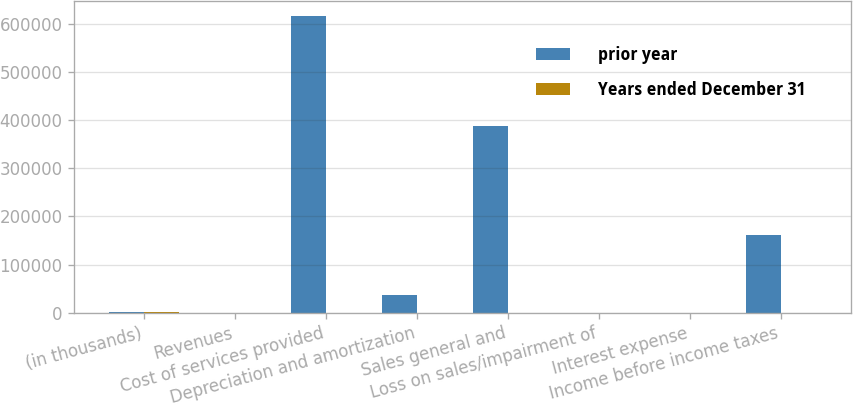Convert chart. <chart><loc_0><loc_0><loc_500><loc_500><stacked_bar_chart><ecel><fcel>(in thousands)<fcel>Revenues<fcel>Cost of services provided<fcel>Depreciation and amortization<fcel>Sales general and<fcel>Loss on sales/impairment of<fcel>Interest expense<fcel>Income before income taxes<nl><fcel>prior year<fcel>2011<fcel>405<fcel>616842<fcel>37503<fcel>388710<fcel>405<fcel>508<fcel>161096<nl><fcel>Years ended December 31<fcel>2011<fcel>6<fcel>5.8<fcel>3<fcel>4.1<fcel>229.3<fcel>16.2<fcel>12.2<nl></chart> 